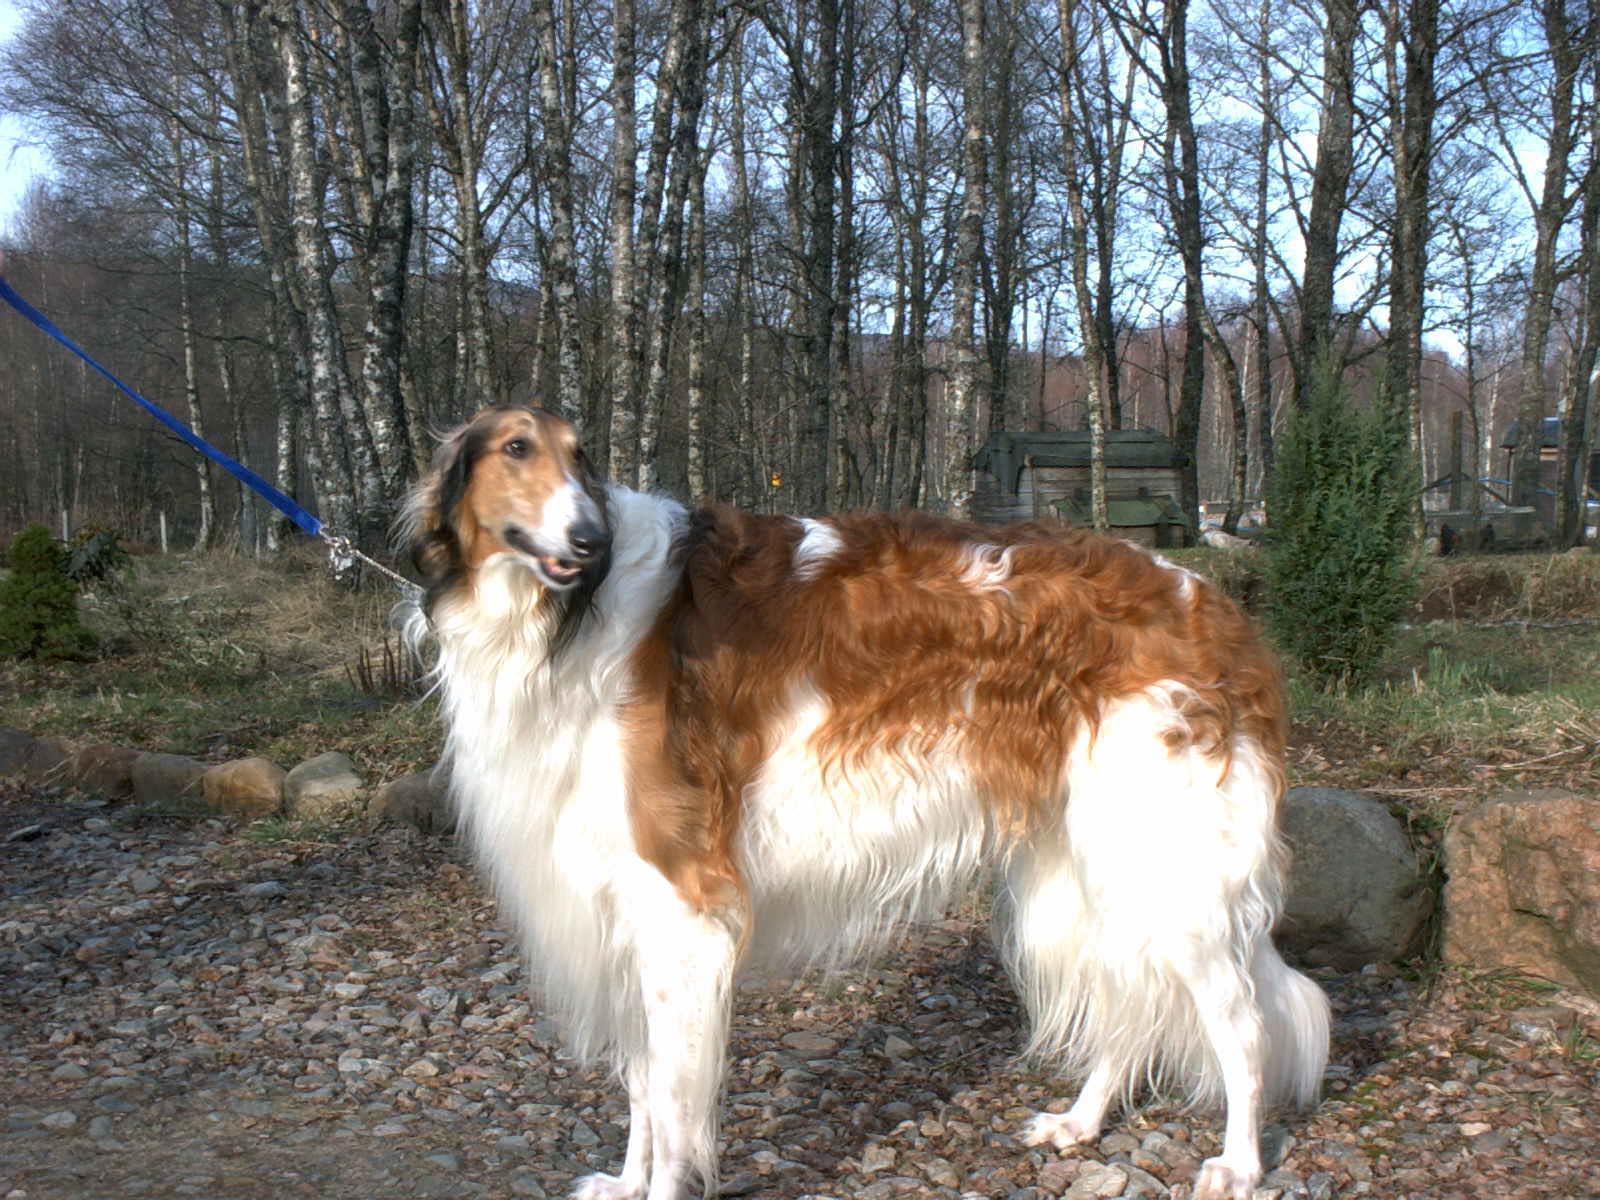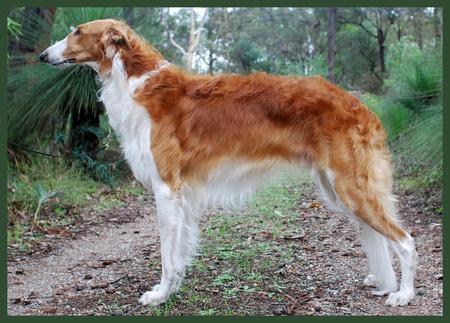The first image is the image on the left, the second image is the image on the right. Evaluate the accuracy of this statement regarding the images: "One dog's mouth is open and the other dog's mouth is closed.". Is it true? Answer yes or no. Yes. The first image is the image on the left, the second image is the image on the right. Evaluate the accuracy of this statement regarding the images: "All dogs are orange-and-white hounds standing with their bodies turned to the left, but one dog is looking back over its shoulder.". Is it true? Answer yes or no. Yes. 